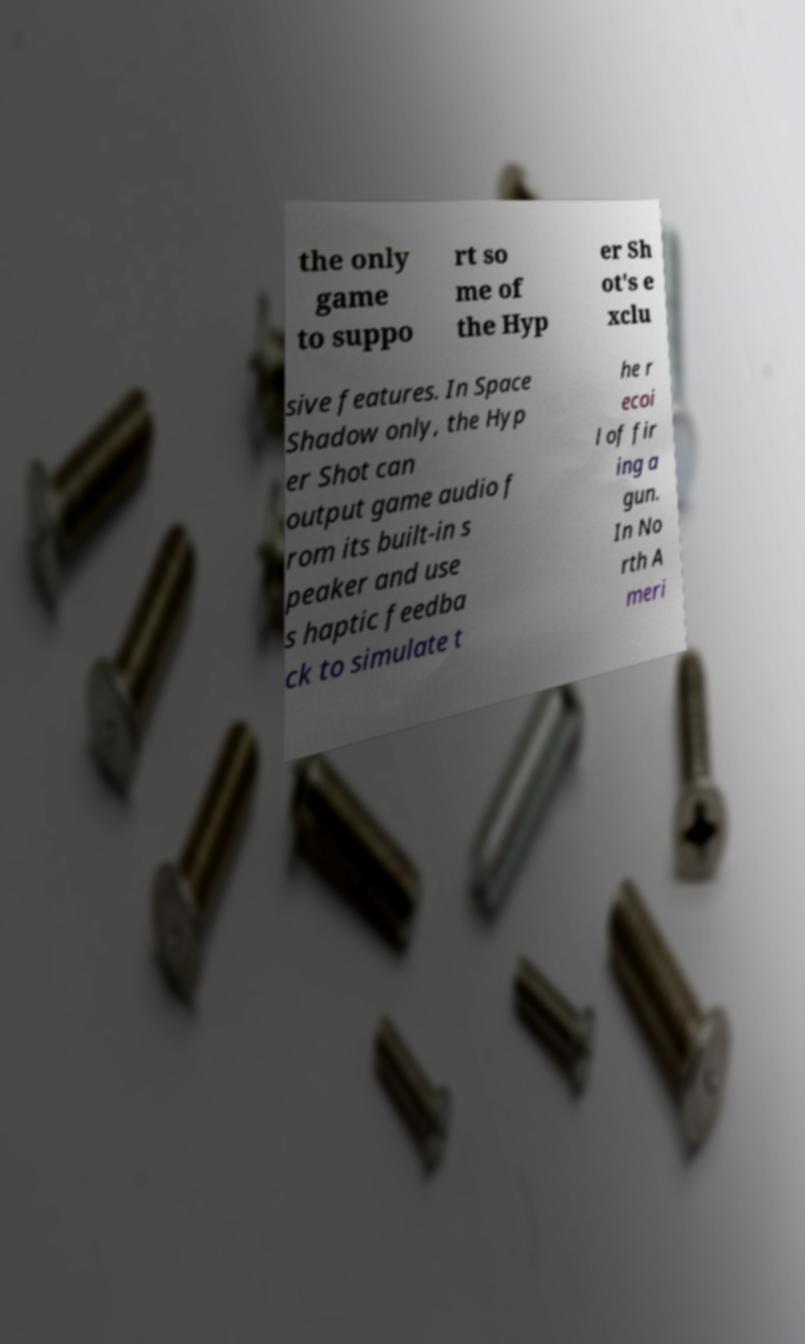There's text embedded in this image that I need extracted. Can you transcribe it verbatim? the only game to suppo rt so me of the Hyp er Sh ot's e xclu sive features. In Space Shadow only, the Hyp er Shot can output game audio f rom its built-in s peaker and use s haptic feedba ck to simulate t he r ecoi l of fir ing a gun. In No rth A meri 